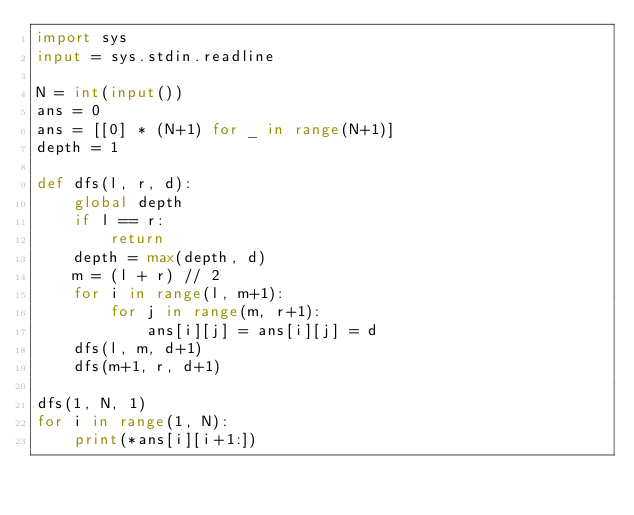Convert code to text. <code><loc_0><loc_0><loc_500><loc_500><_Python_>import sys
input = sys.stdin.readline

N = int(input())
ans = 0
ans = [[0] * (N+1) for _ in range(N+1)]
depth = 1

def dfs(l, r, d):
    global depth
    if l == r:
        return
    depth = max(depth, d)
    m = (l + r) // 2
    for i in range(l, m+1):
        for j in range(m, r+1):
            ans[i][j] = ans[i][j] = d
    dfs(l, m, d+1)
    dfs(m+1, r, d+1)

dfs(1, N, 1)
for i in range(1, N):
    print(*ans[i][i+1:])</code> 